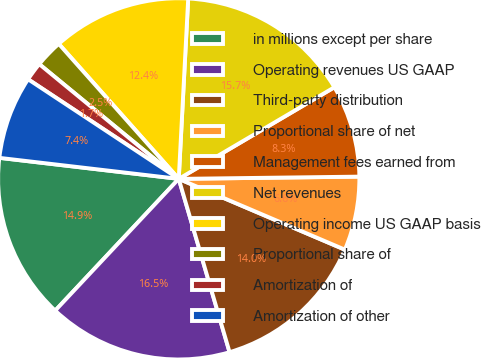<chart> <loc_0><loc_0><loc_500><loc_500><pie_chart><fcel>in millions except per share<fcel>Operating revenues US GAAP<fcel>Third-party distribution<fcel>Proportional share of net<fcel>Management fees earned from<fcel>Net revenues<fcel>Operating income US GAAP basis<fcel>Proportional share of<fcel>Amortization of<fcel>Amortization of other<nl><fcel>14.87%<fcel>16.53%<fcel>14.05%<fcel>6.61%<fcel>8.27%<fcel>15.7%<fcel>12.4%<fcel>2.48%<fcel>1.66%<fcel>7.44%<nl></chart> 